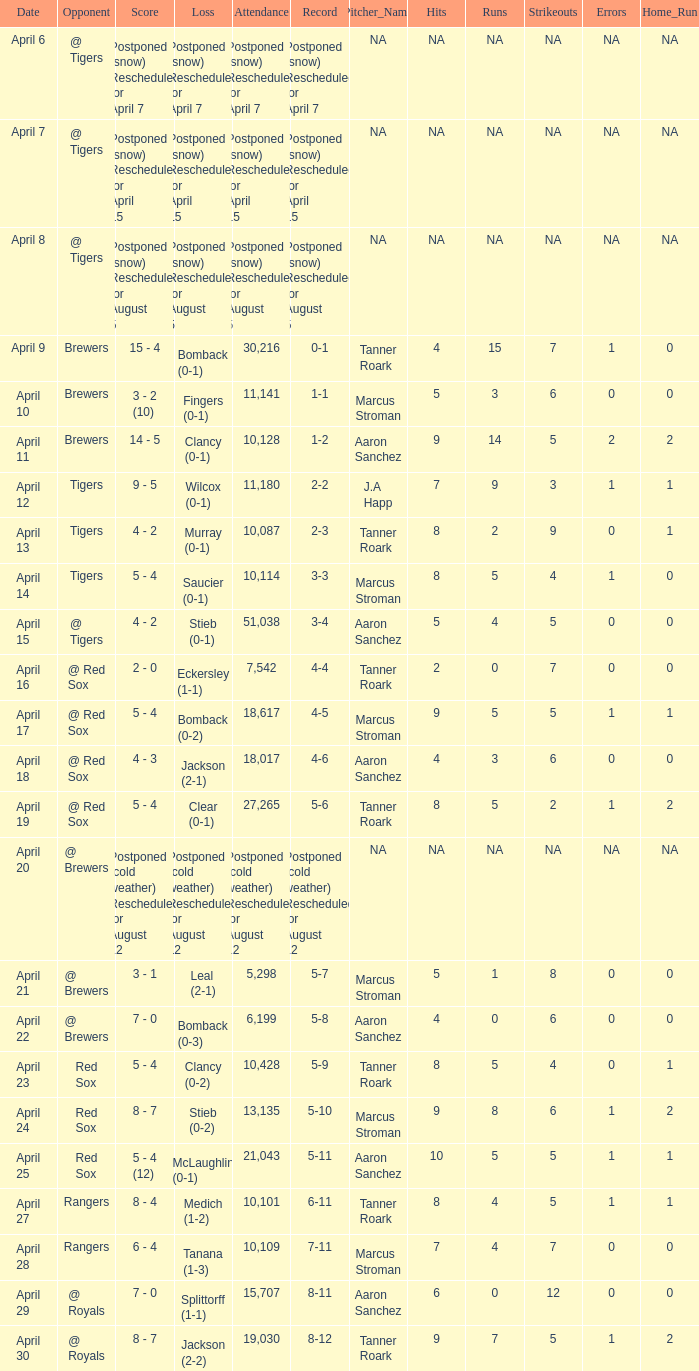What is the score for the game that has an attendance of 5,298? 3 - 1. 